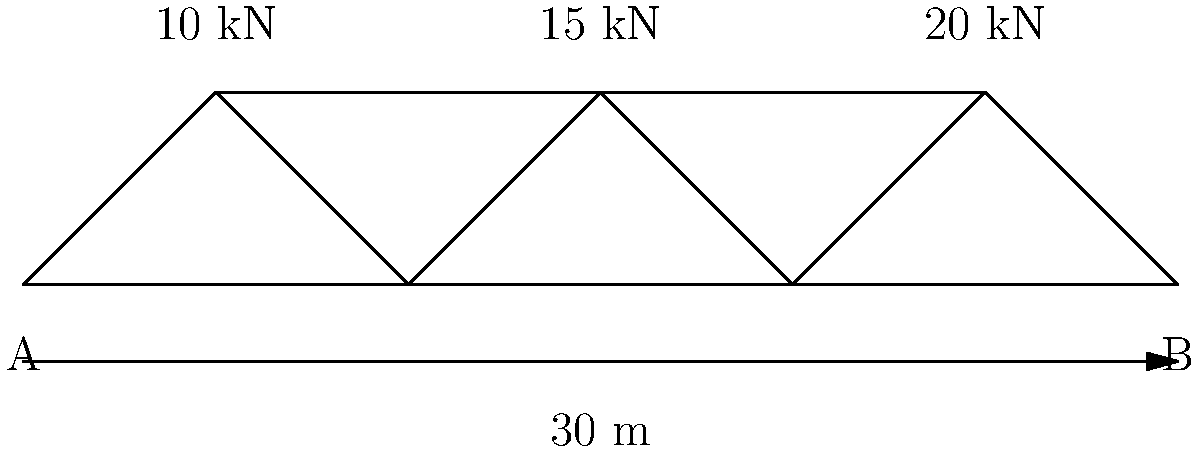A truss bridge structure is shown above with three vertical loads applied at the joints: 10 kN, 15 kN, and 20 kN. The bridge span is 30 m with simple supports at A and B. Calculate the reaction forces at supports A and B. To solve this problem, we'll use the principles of statics and follow these steps:

1. Sum up all the vertical forces:
   $\sum F_y = 10 \text{ kN} + 15 \text{ kN} + 20 \text{ kN} = 45 \text{ kN}$

2. Set up the equation for the sum of moments about point A:
   $\sum M_A = 0$
   $(10 \text{ kN} \cdot 10 \text{ m}) + (15 \text{ kN} \cdot 15 \text{ m}) + (20 \text{ kN} \cdot 25 \text{ m}) - (R_B \cdot 30 \text{ m}) = 0$

3. Solve for $R_B$:
   $R_B = \frac{100 + 225 + 500}{30} = \frac{825}{30} = 27.5 \text{ kN}$

4. Use the equation $\sum F_y = 0$ to solve for $R_A$:
   $R_A + R_B - 45 \text{ kN} = 0$
   $R_A = 45 \text{ kN} - 27.5 \text{ kN} = 17.5 \text{ kN}$

5. Verify the results:
   $R_A + R_B = 17.5 \text{ kN} + 27.5 \text{ kN} = 45 \text{ kN}$
   This equals the sum of the applied loads, confirming our calculations.
Answer: $R_A = 17.5 \text{ kN}$, $R_B = 27.5 \text{ kN}$ 